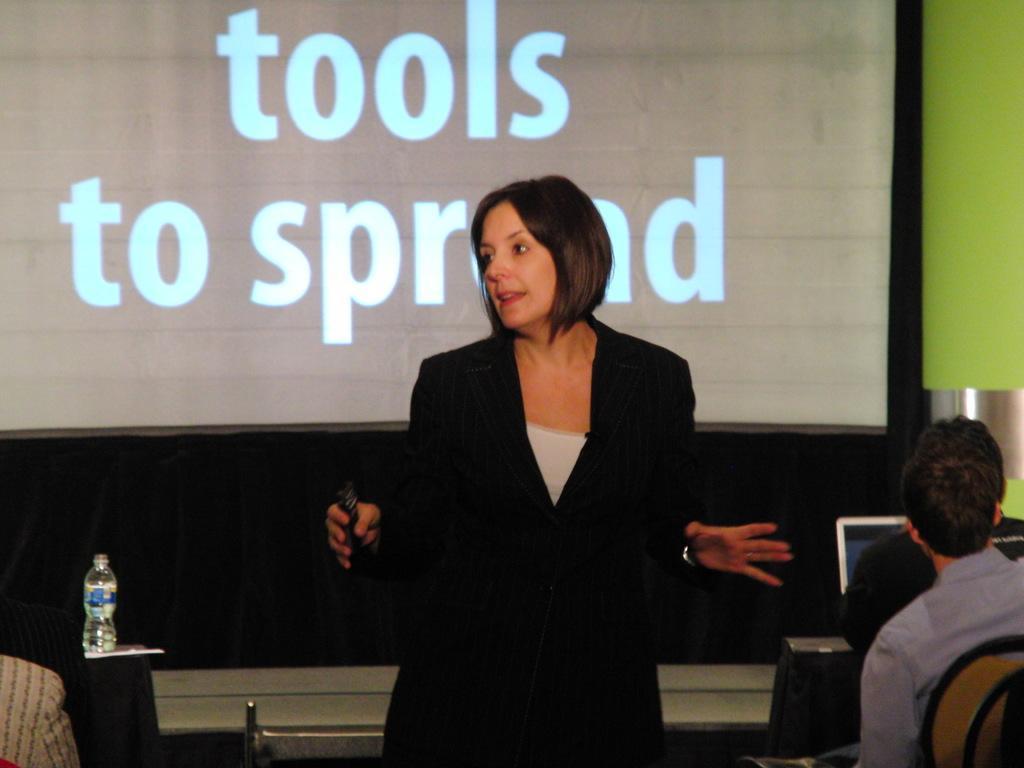Describe this image in one or two sentences. In this picture we can see woman standing in middle holding remote in her hand and talking and beside to her we can see two persons sitting on chair and in front of them there is laptop and on left side we can see bottom, screen. 